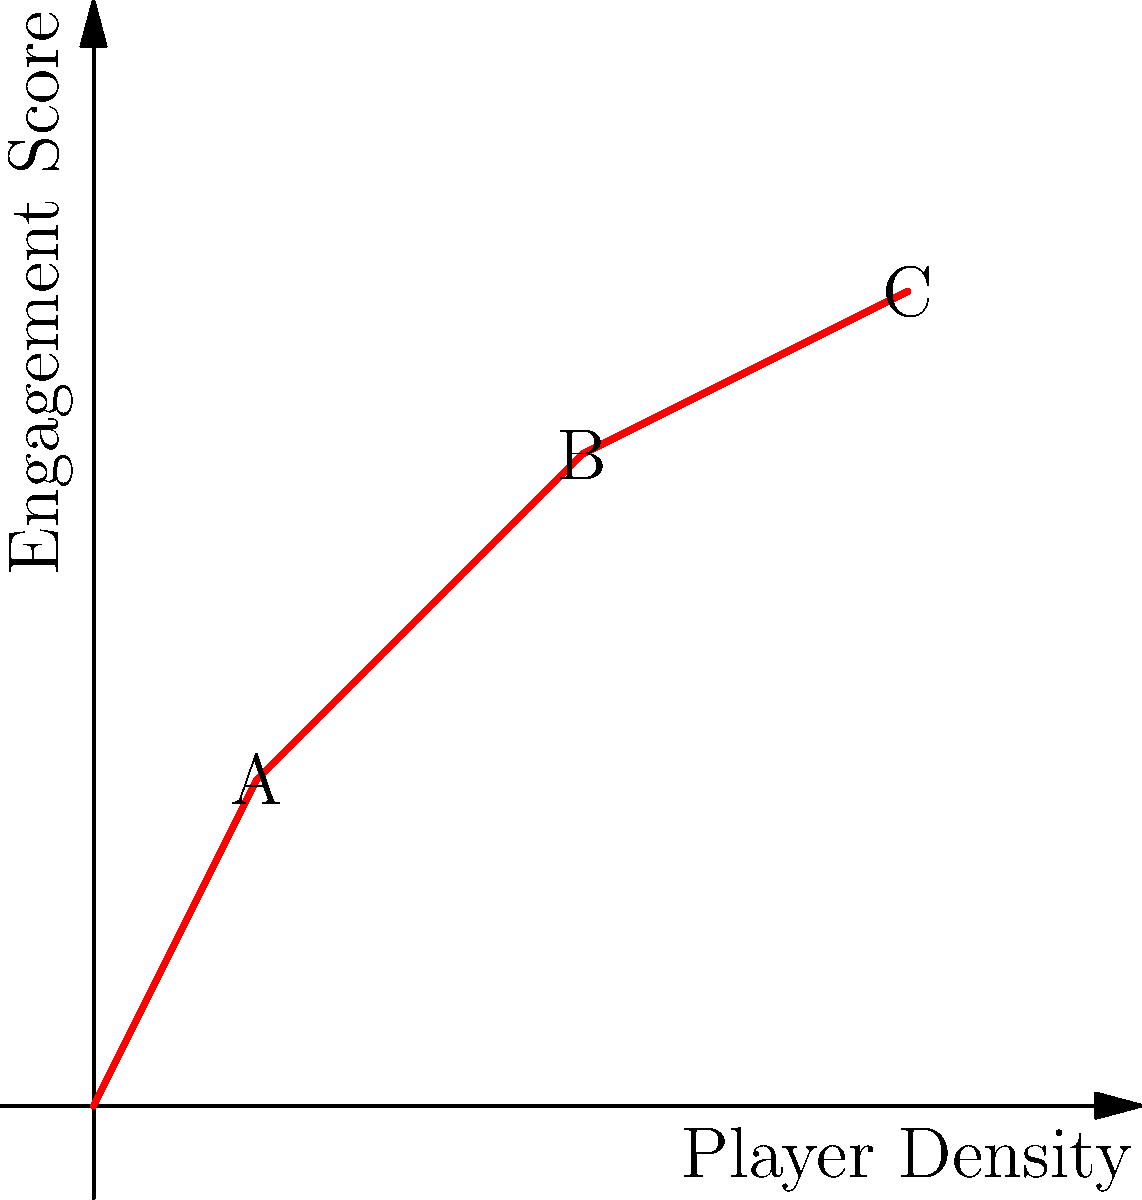Given the heatmap-derived engagement curve for a level layout in the Duality game engine, which area of the level (A, B, or C) would you recommend focusing on to potentially increase overall player engagement? To answer this question, we need to analyze the engagement curve derived from the heatmap data:

1. The x-axis represents player density (how many players are in a particular area), while the y-axis shows the engagement score.

2. Point A (1,2): Low player density with relatively low engagement.
3. Point B (3,4): Moderate player density with good engagement.
4. Point C (5,5): High player density with high engagement.

5. The curve shows a positive correlation between player density and engagement, but the rate of increase slows down as we move from B to C.

6. The steepest part of the curve is between A and B, indicating that this is where we can potentially see the biggest gains in engagement for increases in player density.

7. Focusing on area A could potentially move more players into the B range, which would result in a significant increase in engagement.

8. While C has the highest engagement, the curve is flattening out, suggesting diminishing returns for further increasing player density in this area.

Therefore, the area with the most potential for increasing overall player engagement is A. By improving this area to attract more players, we could potentially see the largest increase in overall engagement scores.
Answer: A 